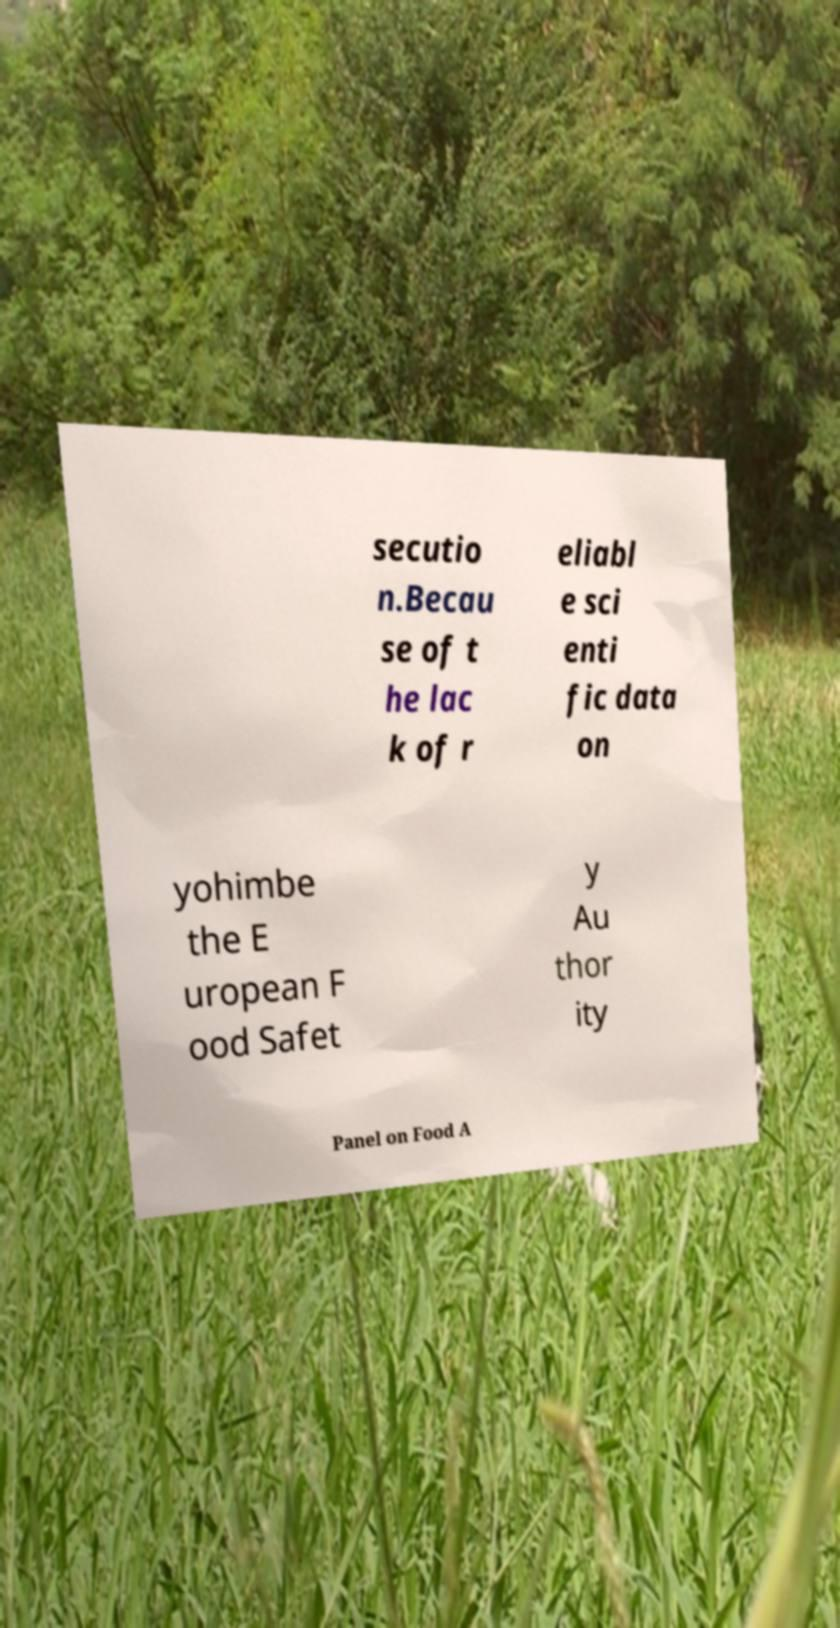Could you assist in decoding the text presented in this image and type it out clearly? secutio n.Becau se of t he lac k of r eliabl e sci enti fic data on yohimbe the E uropean F ood Safet y Au thor ity Panel on Food A 